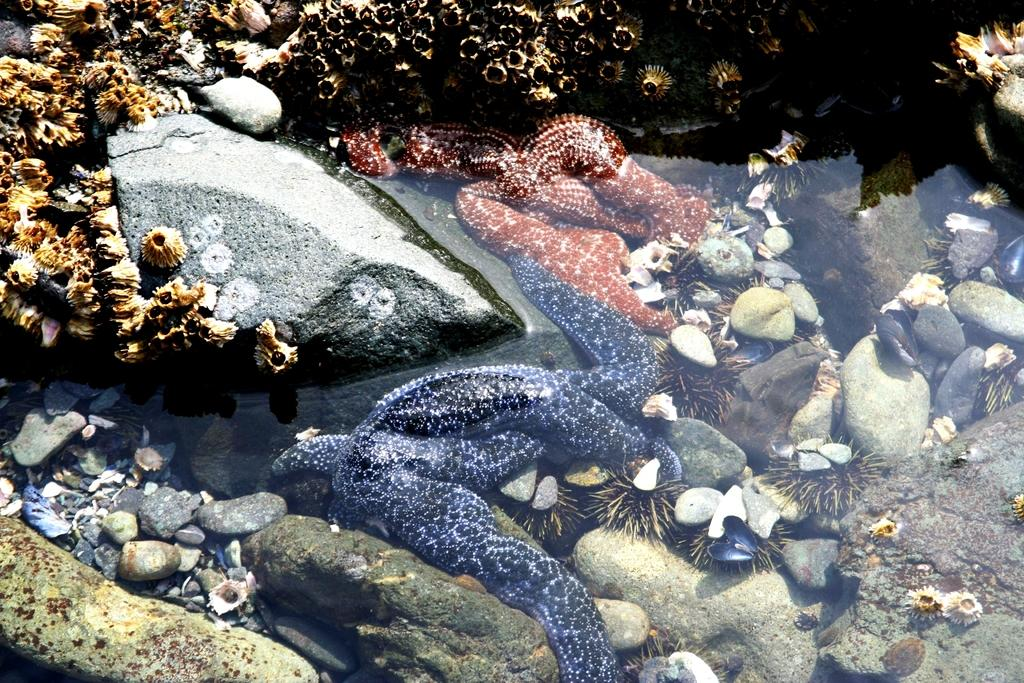What type of animals can be seen in the image? There are water animals in the image. What other creatures can be seen in the background of the image? There are reptiles and shells in the background of the image. What else is present in the background of the image? There are rocks in the background of the image. What type of toothpaste is being used by the minister in the image? There is no toothpaste or minister present in the image. How many pizzas are visible in the image? There are no pizzas present in the image. 